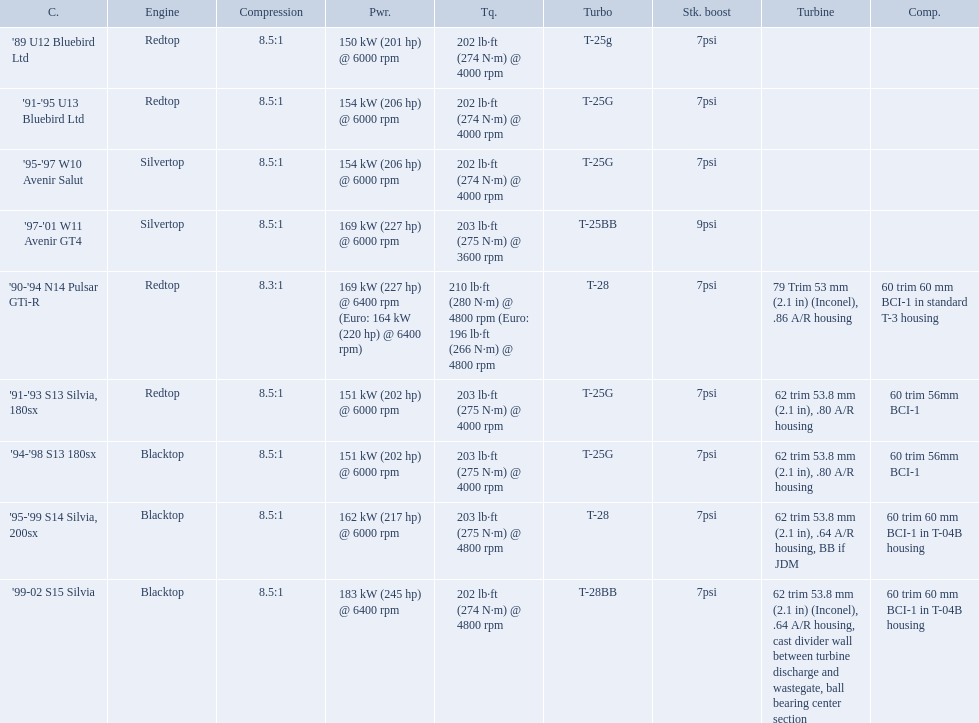Which cars featured blacktop engines? '94-'98 S13 180sx, '95-'99 S14 Silvia, 200sx, '99-02 S15 Silvia. Which of these had t-04b compressor housings? '95-'99 S14 Silvia, 200sx, '99-02 S15 Silvia. Which one of these has the highest horsepower? '99-02 S15 Silvia. What are the listed hp of the cars? 150 kW (201 hp) @ 6000 rpm, 154 kW (206 hp) @ 6000 rpm, 154 kW (206 hp) @ 6000 rpm, 169 kW (227 hp) @ 6000 rpm, 169 kW (227 hp) @ 6400 rpm (Euro: 164 kW (220 hp) @ 6400 rpm), 151 kW (202 hp) @ 6000 rpm, 151 kW (202 hp) @ 6000 rpm, 162 kW (217 hp) @ 6000 rpm, 183 kW (245 hp) @ 6400 rpm. Which is the only car with over 230 hp? '99-02 S15 Silvia. What are all of the cars? '89 U12 Bluebird Ltd, '91-'95 U13 Bluebird Ltd, '95-'97 W10 Avenir Salut, '97-'01 W11 Avenir GT4, '90-'94 N14 Pulsar GTi-R, '91-'93 S13 Silvia, 180sx, '94-'98 S13 180sx, '95-'99 S14 Silvia, 200sx, '99-02 S15 Silvia. What is their rated power? 150 kW (201 hp) @ 6000 rpm, 154 kW (206 hp) @ 6000 rpm, 154 kW (206 hp) @ 6000 rpm, 169 kW (227 hp) @ 6000 rpm, 169 kW (227 hp) @ 6400 rpm (Euro: 164 kW (220 hp) @ 6400 rpm), 151 kW (202 hp) @ 6000 rpm, 151 kW (202 hp) @ 6000 rpm, 162 kW (217 hp) @ 6000 rpm, 183 kW (245 hp) @ 6400 rpm. Which car has the most power? '99-02 S15 Silvia. 